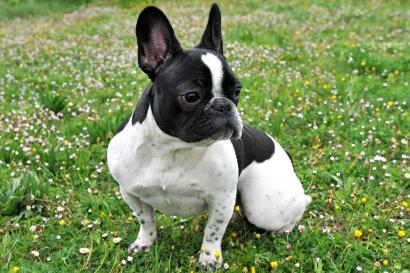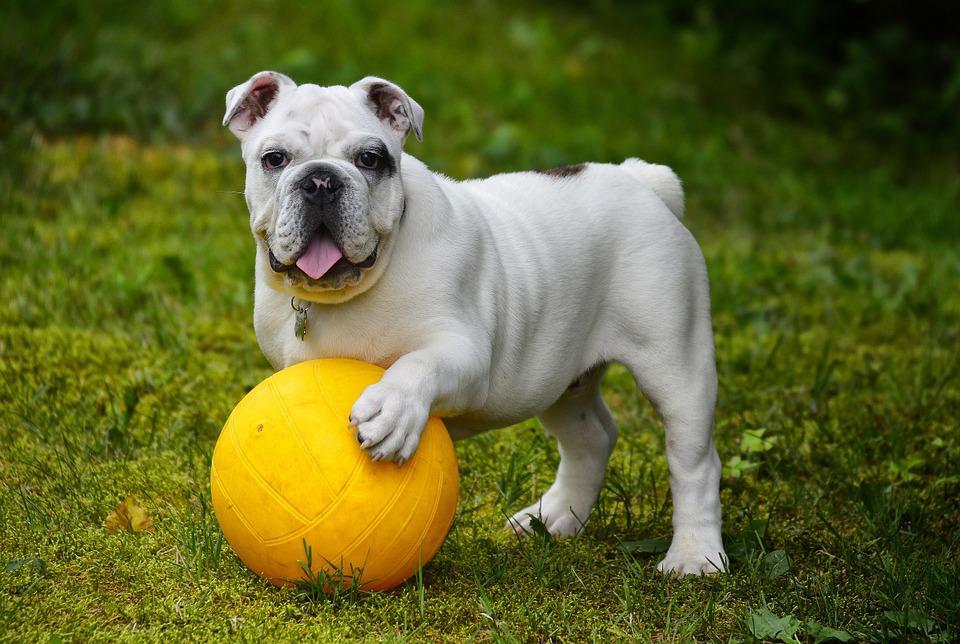The first image is the image on the left, the second image is the image on the right. Given the left and right images, does the statement "Two small dogs with ears standing up have no collar or leash." hold true? Answer yes or no. No. 